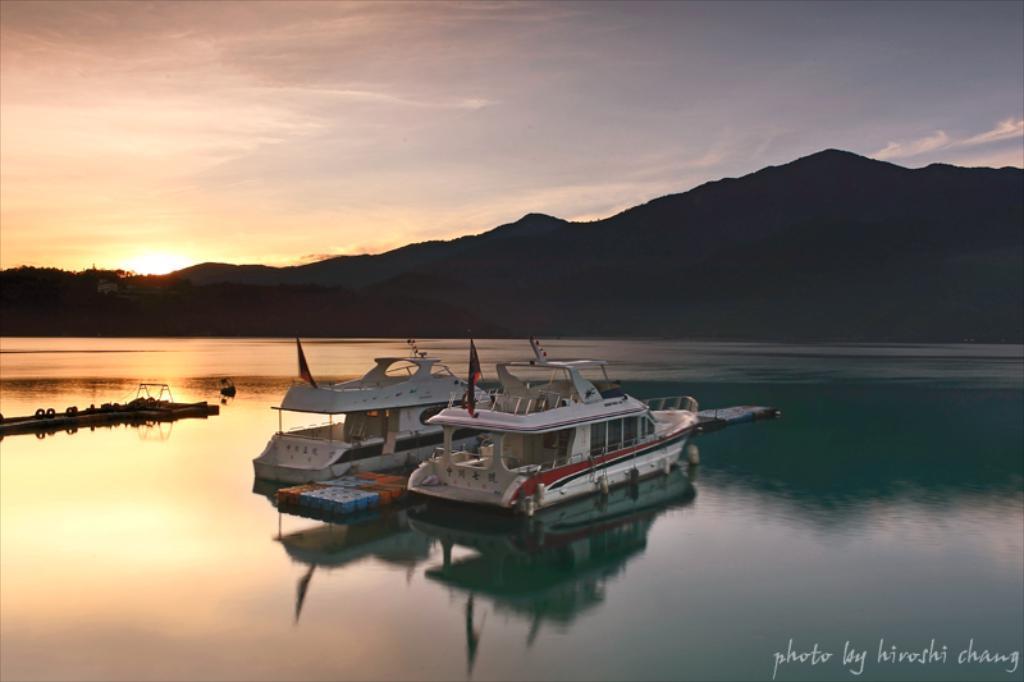How would you summarize this image in a sentence or two? In this image in the center there are ships sailing on the water. In the background there are mountains and at the top we can see clouds in the sky, at the bottom right of the image there is some text written on it and in the center there are objects which are visible. 